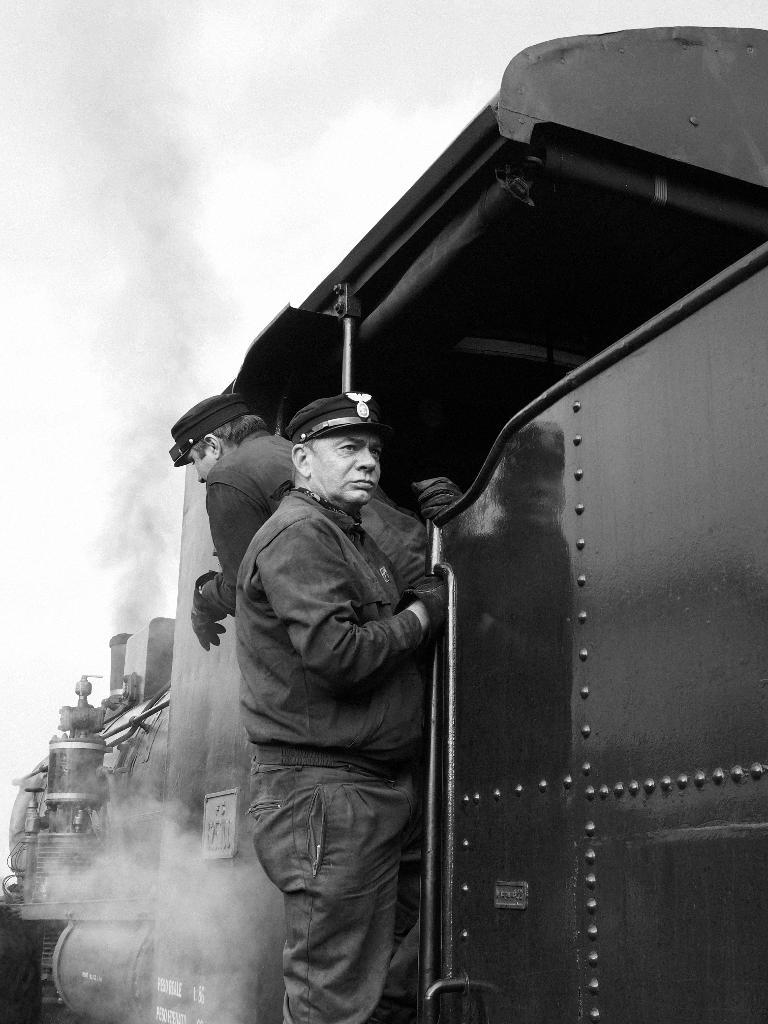What are the people at the entrance of the train doing? The people are standing at the entrance of the train. What are the people wearing? The people are wearing uniforms. What can be seen coming from the train? There is smoke coming from the train. What type of popcorn is being sold by the ghost at the entrance of the train? There is no ghost or popcorn present in the image. What kind of produce is visible near the train? There is no produce visible near the train; the focus is on the people and the train itself. 